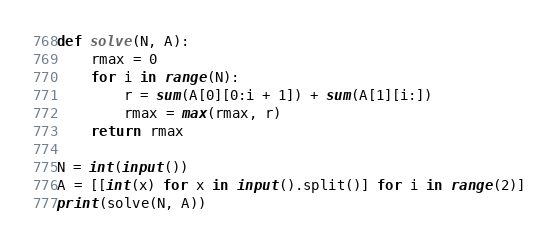Convert code to text. <code><loc_0><loc_0><loc_500><loc_500><_Python_>def solve(N, A):
    rmax = 0
    for i in range(N):
        r = sum(A[0][0:i + 1]) + sum(A[1][i:])
        rmax = max(rmax, r)
    return rmax

N = int(input())
A = [[int(x) for x in input().split()] for i in range(2)]
print(solve(N, A))
</code> 